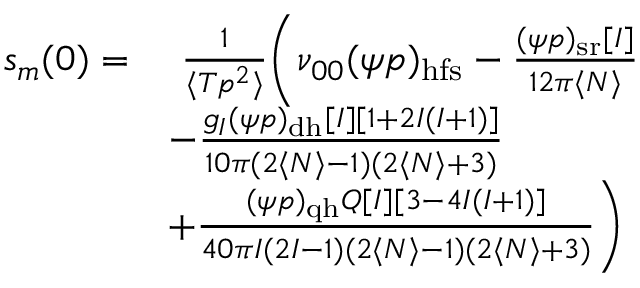Convert formula to latex. <formula><loc_0><loc_0><loc_500><loc_500>\begin{array} { r l } { s _ { m } ( 0 ) = } & { \frac { 1 } { \langle T p ^ { 2 } \rangle } \left ( \nu _ { 0 0 } ( \psi p ) _ { h f s } - \frac { ( \psi p ) _ { s r } [ I ] } { 1 2 \pi \langle N \rangle } } \\ & { - \frac { g _ { I } ( \psi p ) _ { d h } [ I ] [ 1 + 2 I ( I + 1 ) ] } { 1 0 \pi ( 2 \langle N \rangle - 1 ) ( 2 \langle N \rangle + 3 ) } } \\ & { + \frac { ( \psi p ) _ { q h } Q [ I ] [ 3 - 4 I ( I + 1 ) ] } { 4 0 \pi I ( 2 I - 1 ) ( 2 \langle N \rangle - 1 ) ( 2 \langle N \rangle + 3 ) } \right ) } \end{array}</formula> 